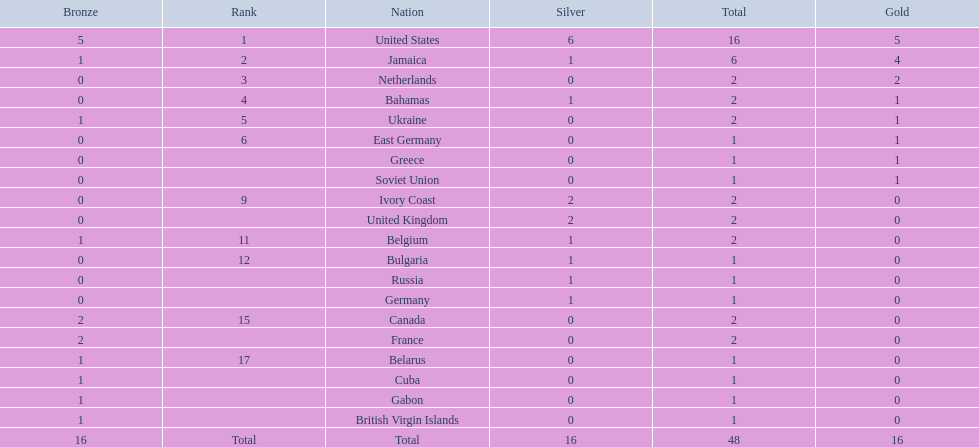Can you give me this table in json format? {'header': ['Bronze', 'Rank', 'Nation', 'Silver', 'Total', 'Gold'], 'rows': [['5', '1', 'United States', '6', '16', '5'], ['1', '2', 'Jamaica', '1', '6', '4'], ['0', '3', 'Netherlands', '0', '2', '2'], ['0', '4', 'Bahamas', '1', '2', '1'], ['1', '5', 'Ukraine', '0', '2', '1'], ['0', '6', 'East Germany', '0', '1', '1'], ['0', '', 'Greece', '0', '1', '1'], ['0', '', 'Soviet Union', '0', '1', '1'], ['0', '9', 'Ivory Coast', '2', '2', '0'], ['0', '', 'United Kingdom', '2', '2', '0'], ['1', '11', 'Belgium', '1', '2', '0'], ['0', '12', 'Bulgaria', '1', '1', '0'], ['0', '', 'Russia', '1', '1', '0'], ['0', '', 'Germany', '1', '1', '0'], ['2', '15', 'Canada', '0', '2', '0'], ['2', '', 'France', '0', '2', '0'], ['1', '17', 'Belarus', '0', '1', '0'], ['1', '', 'Cuba', '0', '1', '0'], ['1', '', 'Gabon', '0', '1', '0'], ['1', '', 'British Virgin Islands', '0', '1', '0'], ['16', 'Total', 'Total', '16', '48', '16']]} What was the largest number of medals won by any country? 16. Which country won that many medals? United States. 